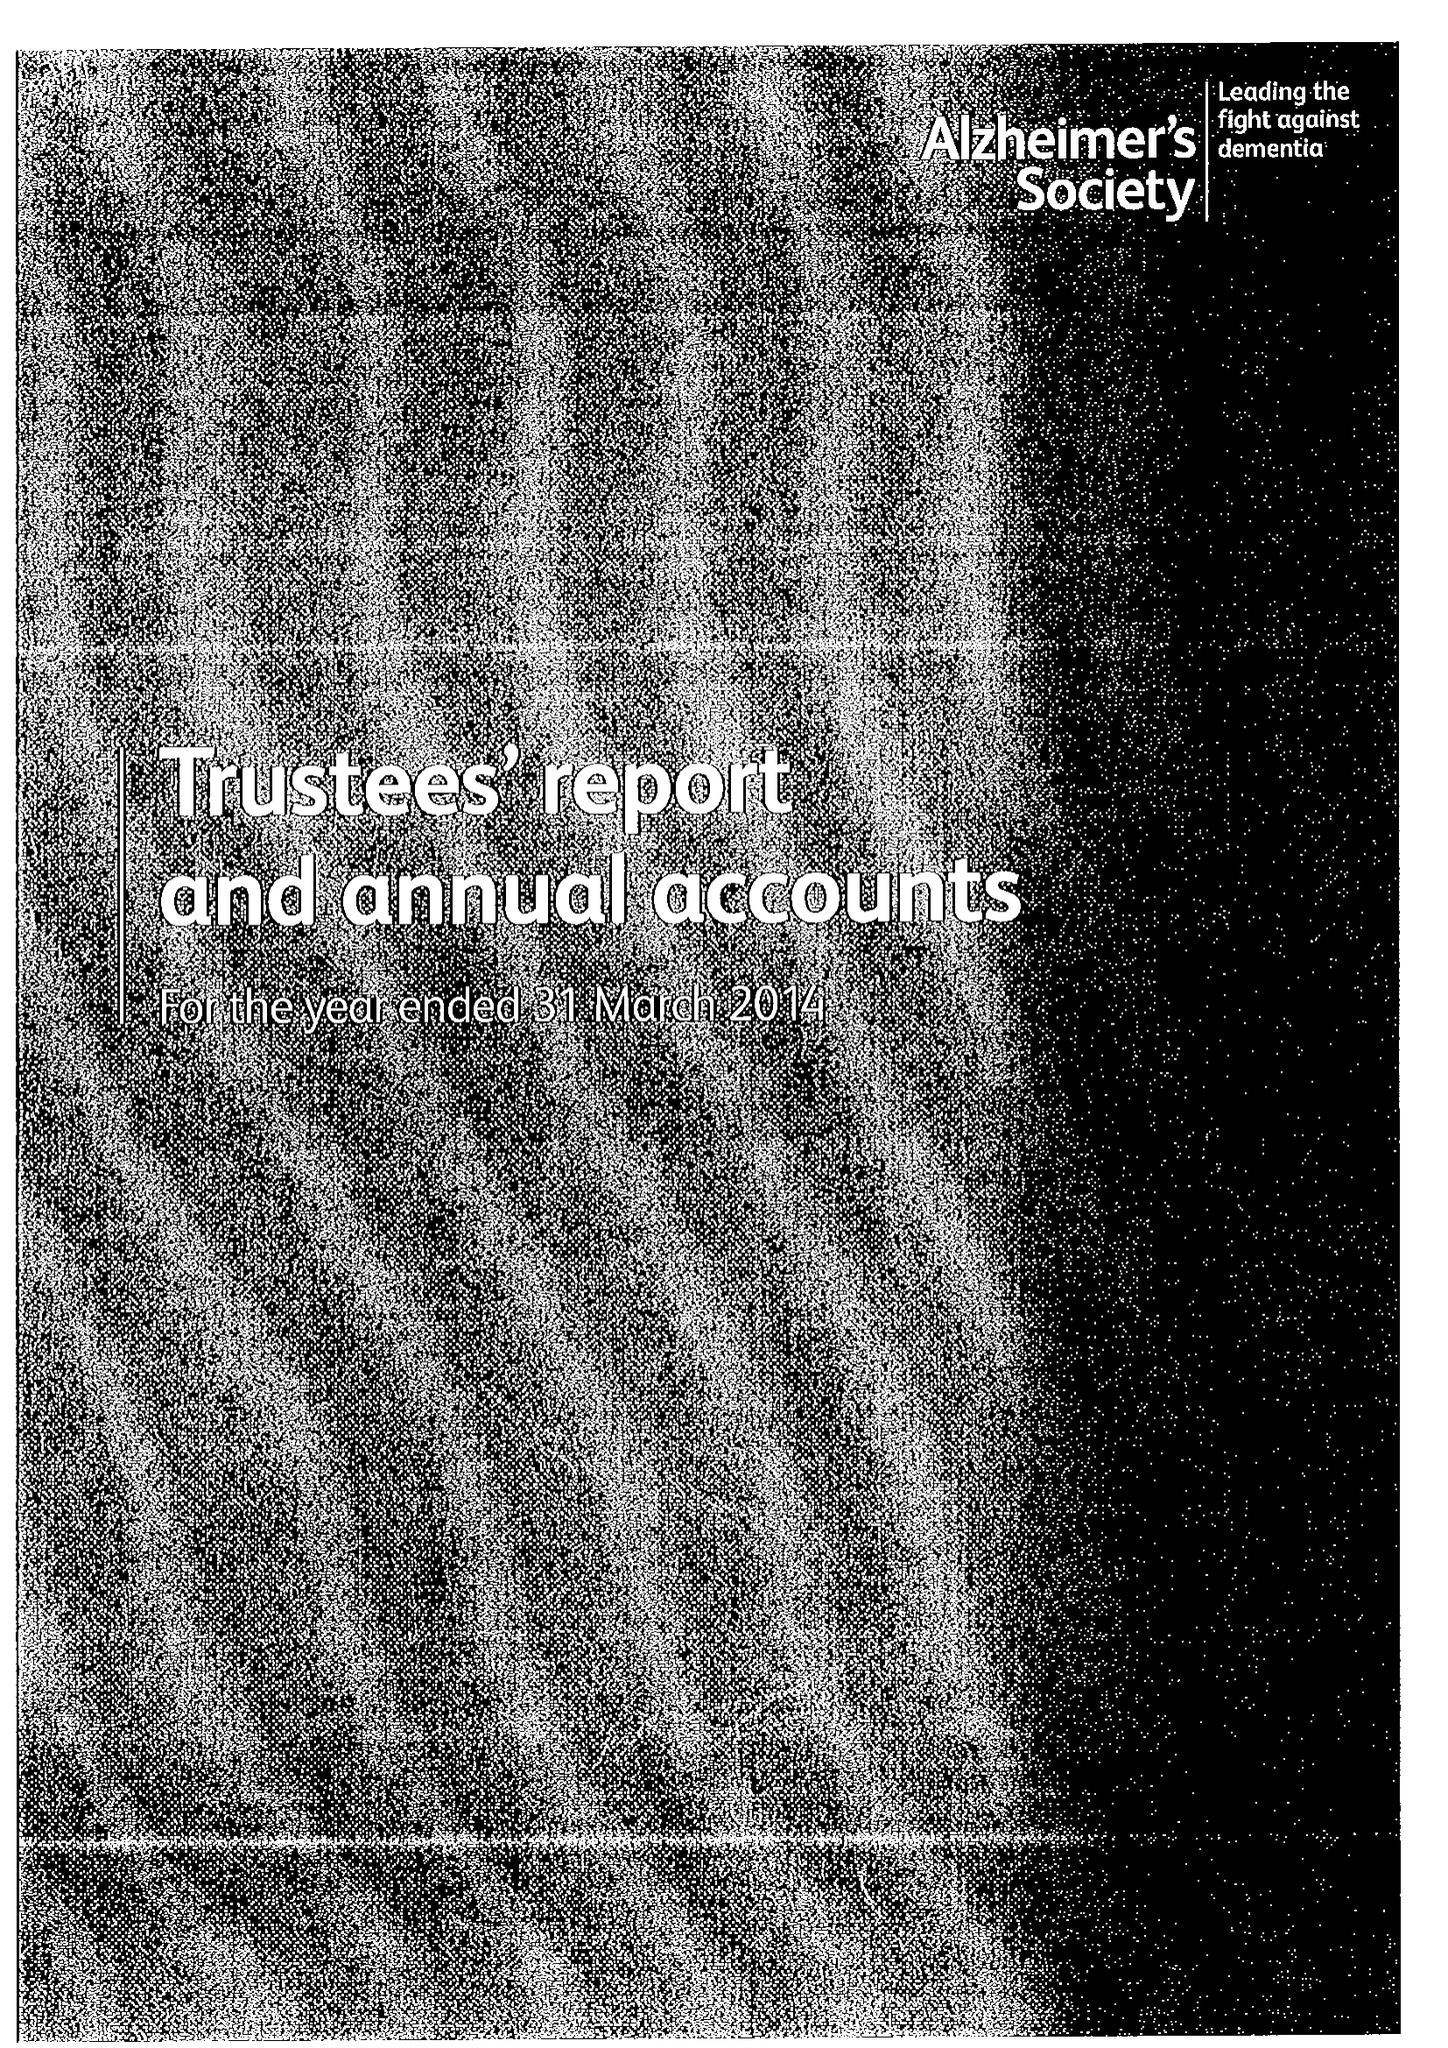What is the value for the address__post_town?
Answer the question using a single word or phrase. LONDON 